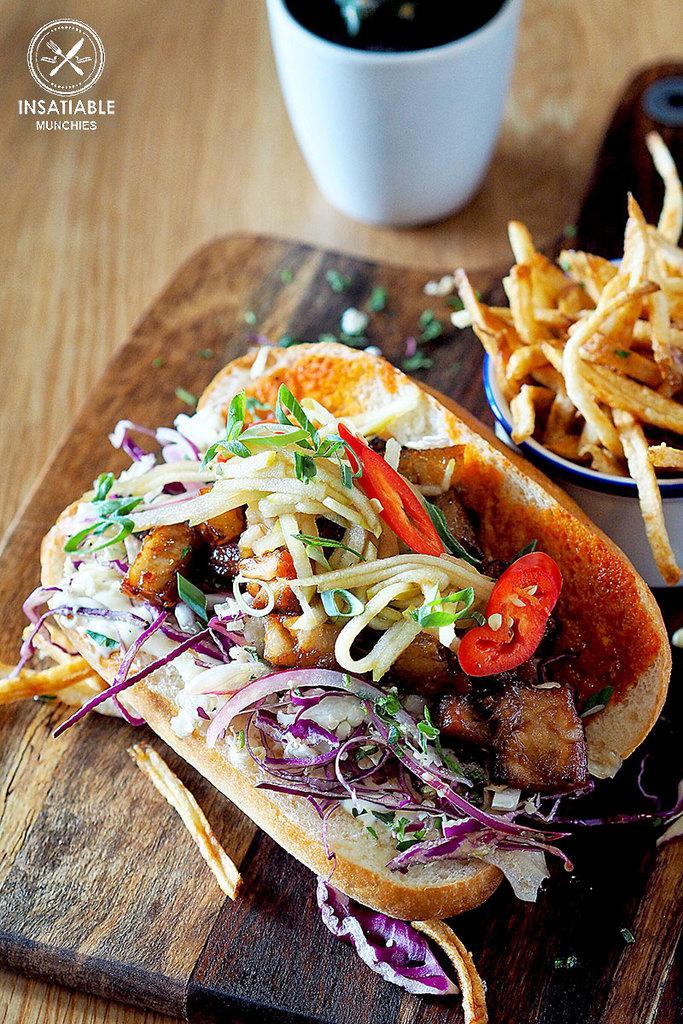Describe this image in one or two sentences. In this image we can see food items on the wooden surface. There is a mug. To the left side top corner of the image there is some text. 